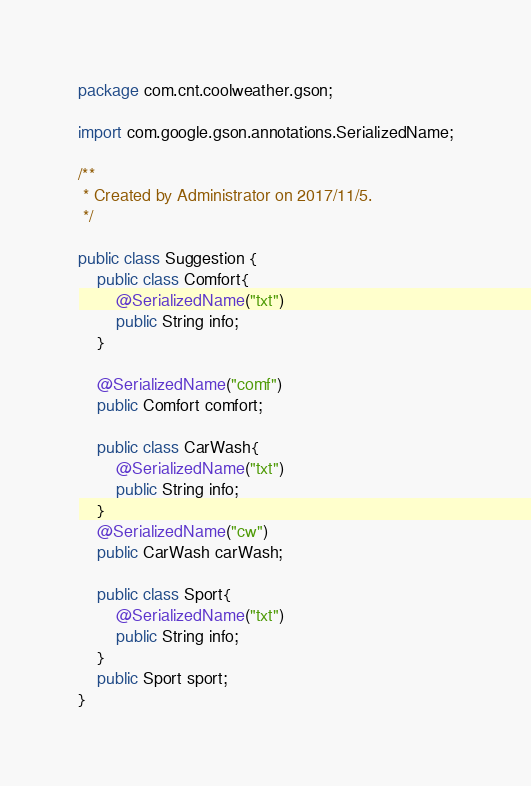<code> <loc_0><loc_0><loc_500><loc_500><_Java_>package com.cnt.coolweather.gson;

import com.google.gson.annotations.SerializedName;

/**
 * Created by Administrator on 2017/11/5.
 */

public class Suggestion {
    public class Comfort{
        @SerializedName("txt")
        public String info;
    }

    @SerializedName("comf")
    public Comfort comfort;

    public class CarWash{
        @SerializedName("txt")
        public String info;
    }
    @SerializedName("cw")
    public CarWash carWash;

    public class Sport{
        @SerializedName("txt")
        public String info;
    }
    public Sport sport;
}
</code> 